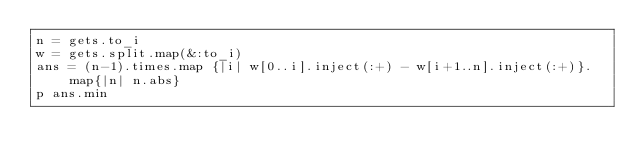<code> <loc_0><loc_0><loc_500><loc_500><_Ruby_>n = gets.to_i
w = gets.split.map(&:to_i)
ans = (n-1).times.map {|i| w[0..i].inject(:+) - w[i+1..n].inject(:+)}.map{|n| n.abs}
p ans.min</code> 